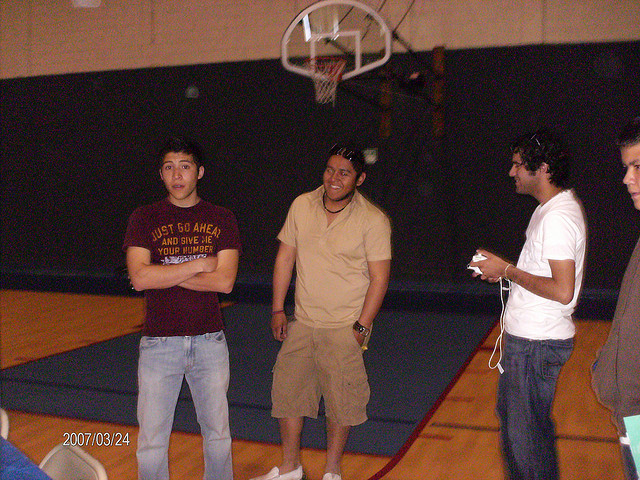What kind of emotions do the individuals in the image seem to be displaying? The person in the middle is smiling, suggesting he is in a positive mood or enjoying the moment. The individuals on either side appear to be focused or observing something attentively, possibly watching a game or waiting for their turn to play. 